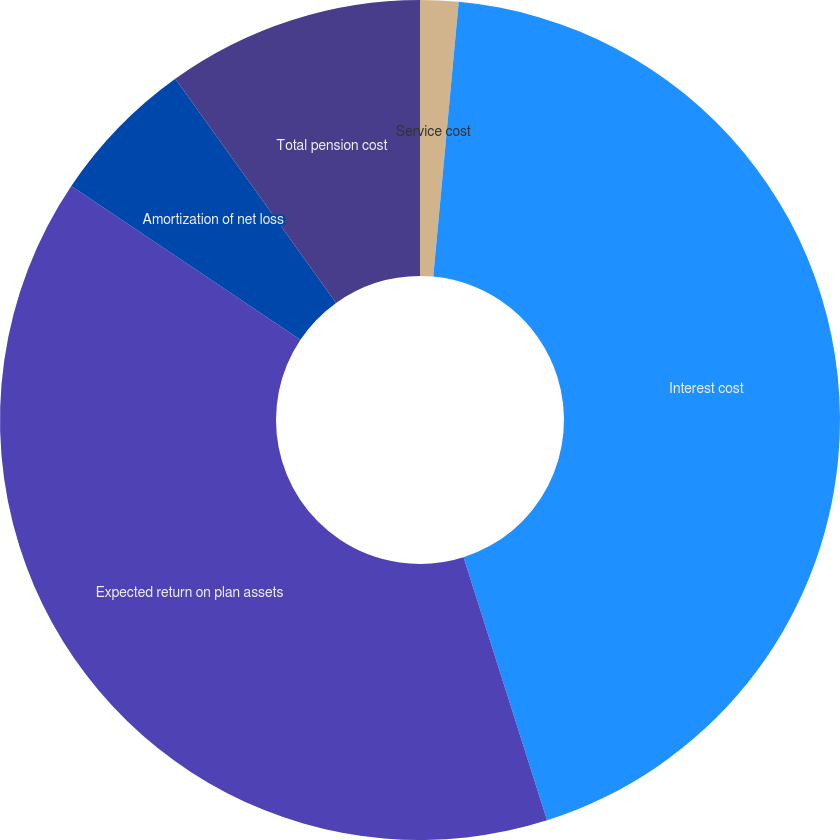Convert chart. <chart><loc_0><loc_0><loc_500><loc_500><pie_chart><fcel>Service cost<fcel>Interest cost<fcel>Expected return on plan assets<fcel>Amortization of net loss<fcel>Total pension cost<nl><fcel>1.47%<fcel>43.64%<fcel>39.3%<fcel>5.69%<fcel>9.9%<nl></chart> 